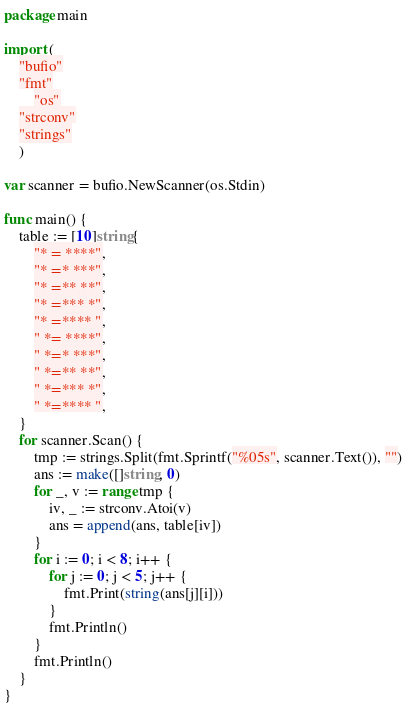<code> <loc_0><loc_0><loc_500><loc_500><_Go_>package main

import (
	"bufio"
	"fmt"
		"os"
	"strconv"
	"strings"
	)

var scanner = bufio.NewScanner(os.Stdin)

func main() {
	table := [10]string{
		"* = ****",
		"* =* ***",
		"* =** **",
		"* =*** *",
		"* =**** ",
		" *= ****",
		" *=* ***",
		" *=** **",
		" *=*** *",
		" *=**** ",
	}
	for scanner.Scan() {
		tmp := strings.Split(fmt.Sprintf("%05s", scanner.Text()), "")
		ans := make([]string, 0)
		for _, v := range tmp {
			iv, _ := strconv.Atoi(v)
			ans = append(ans, table[iv])
		}
		for i := 0; i < 8; i++ {
			for j := 0; j < 5; j++ {
				fmt.Print(string(ans[j][i]))
			}
			fmt.Println()
		}
		fmt.Println()
	}
}

</code> 